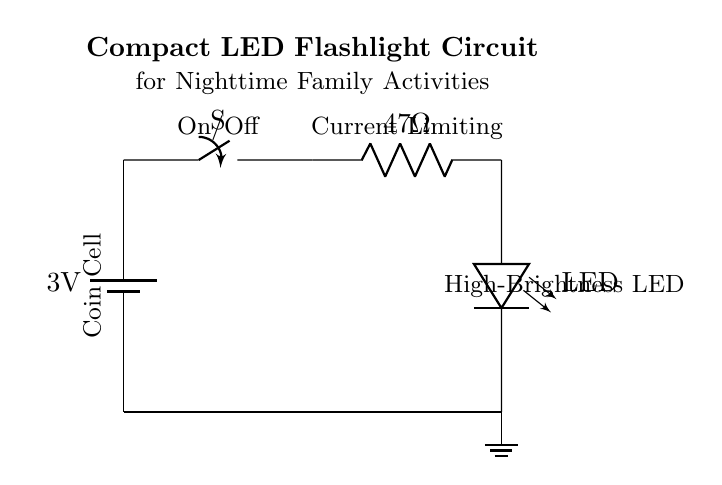What is the voltage of this circuit? The voltage of the circuit is 3 volts, as indicated by the battery label in the circuit diagram.
Answer: 3 volts What type of switch is used in the circuit? The circuit uses a simple on/off switch. This is determined by the "switch" symbol in the diagram, which indicates that it can control the flow of current in the circuit.
Answer: On/Off What is the resistance value of the resistor? The resistance value is 47 Ohms, as shown next to the resistor symbol in the circuit. This value is critical for limiting current to the LED.
Answer: 47 Ohms How many components are in this circuit? There are four main components: a battery, a switch, a resistor, and an LED. Each component serves a specific function to complete the circuit and operate the flashlight.
Answer: Four What is the function of the resistor in this circuit? The resistor limits the current flowing through the LED. This is important because too much current can damage the LED. The resistor value (47 Ohms) is designed to provide appropriate current levels for safe operation.
Answer: Current limiting What is the purpose of the LED in the circuit? The LED (Light Emitting Diode) emits light when current flows through it. In this circuit, it is used as a flashlight, providing illumination for nighttime outdoor activities with family.
Answer: Light emission What is the connection type among the components? The components are connected in a series circuit configuration, as indicated by the continuous paths between the components. This means the same current flows through each component.
Answer: Series connection 